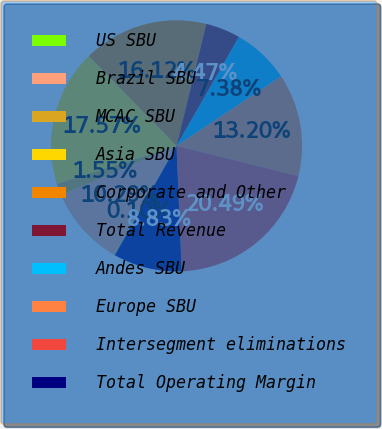<chart> <loc_0><loc_0><loc_500><loc_500><pie_chart><fcel>US SBU<fcel>Brazil SBU<fcel>MCAC SBU<fcel>Asia SBU<fcel>Corporate and Other<fcel>Total Revenue<fcel>Andes SBU<fcel>Europe SBU<fcel>Intersegment eliminations<fcel>Total Operating Margin<nl><fcel>0.1%<fcel>10.29%<fcel>1.55%<fcel>17.57%<fcel>16.12%<fcel>4.47%<fcel>7.38%<fcel>13.2%<fcel>20.49%<fcel>8.83%<nl></chart> 